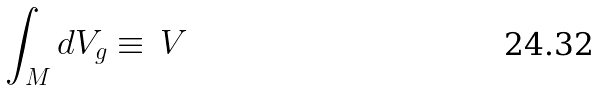Convert formula to latex. <formula><loc_0><loc_0><loc_500><loc_500>\int _ { M } d V _ { g } \equiv \, V</formula> 